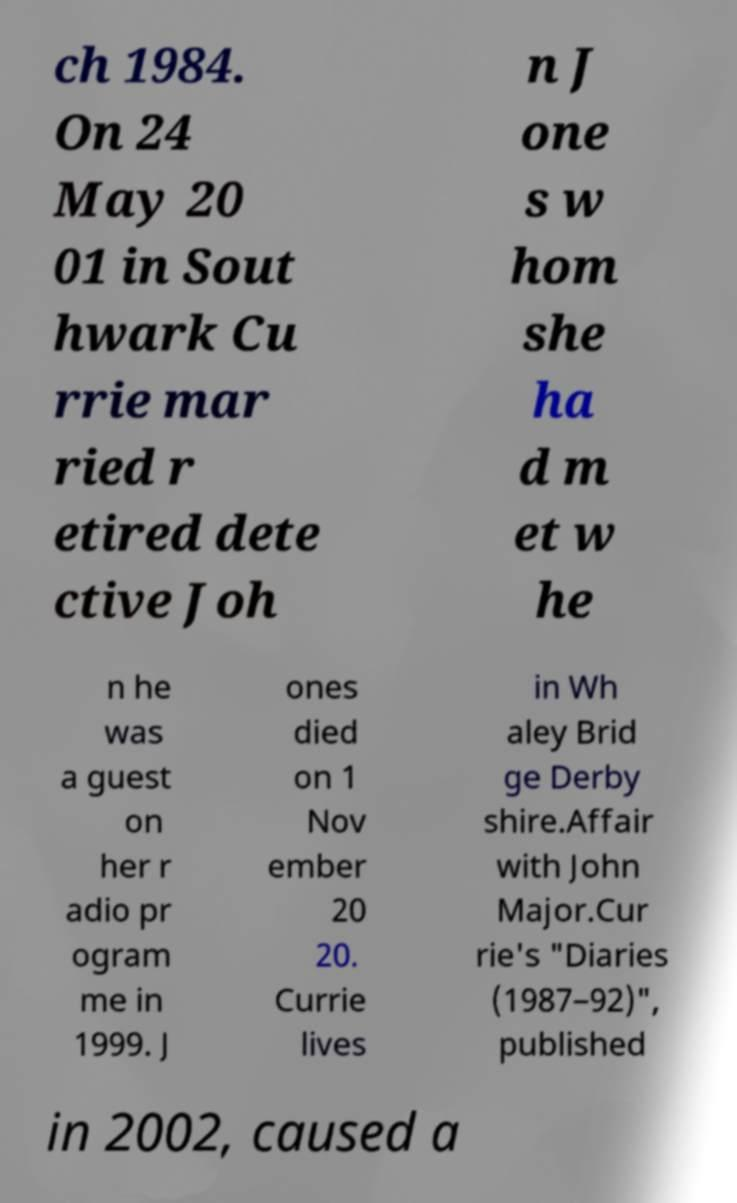Can you accurately transcribe the text from the provided image for me? ch 1984. On 24 May 20 01 in Sout hwark Cu rrie mar ried r etired dete ctive Joh n J one s w hom she ha d m et w he n he was a guest on her r adio pr ogram me in 1999. J ones died on 1 Nov ember 20 20. Currie lives in Wh aley Brid ge Derby shire.Affair with John Major.Cur rie's "Diaries (1987–92)", published in 2002, caused a 